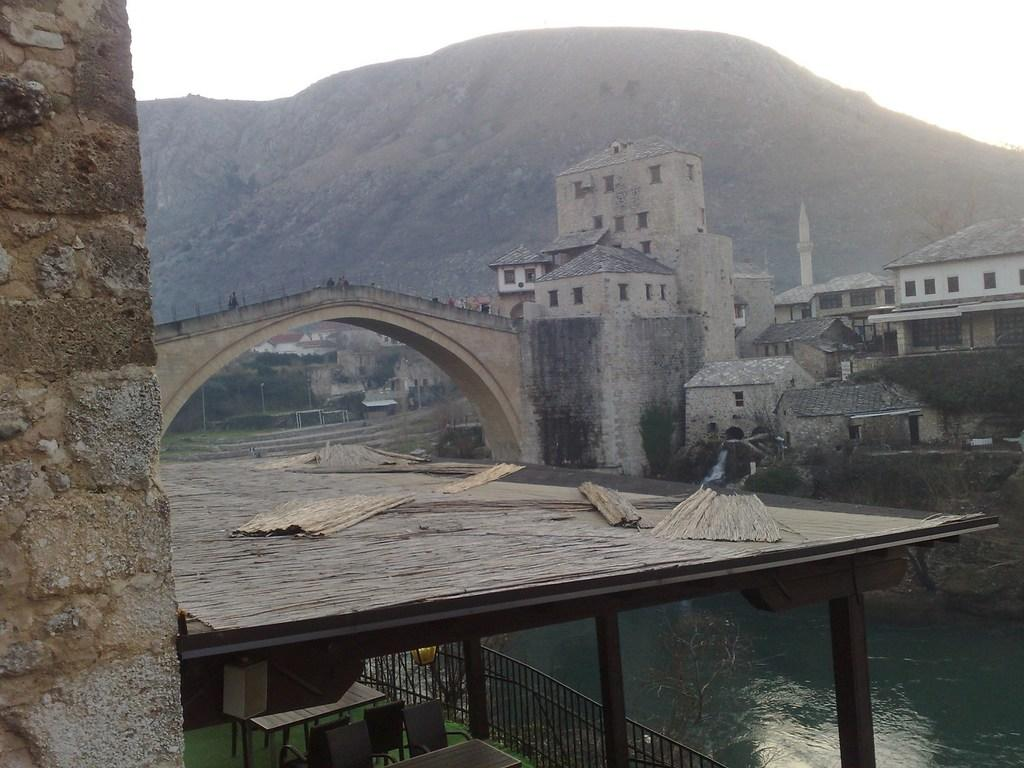What type of structure is present in the image? There is a roof in the image, which suggests the presence of a building or structure. What type of furniture can be seen in the image? Chairs and tables are visible in the image. What natural element is present in the image? Water is visible in the image. What safety feature can be seen in the image? There is a railing in the image. What type of man-made structure is present in the image? There is a bridge in the image. What type of buildings are present in the image? There are buildings in the image. What type of vegetation is present in the image? Trees are visible in the image. What type of geographical feature is visible in the background of the image? There is a mountain visible in the background of the image. What part of the natural environment is visible in the background of the image? The sky is visible in the background of the image. Can you tell me how many houses are burning in the image? There are no houses present in the image, let alone any that are burning. What type of lake can be seen in the image? There is no lake present in the image. 